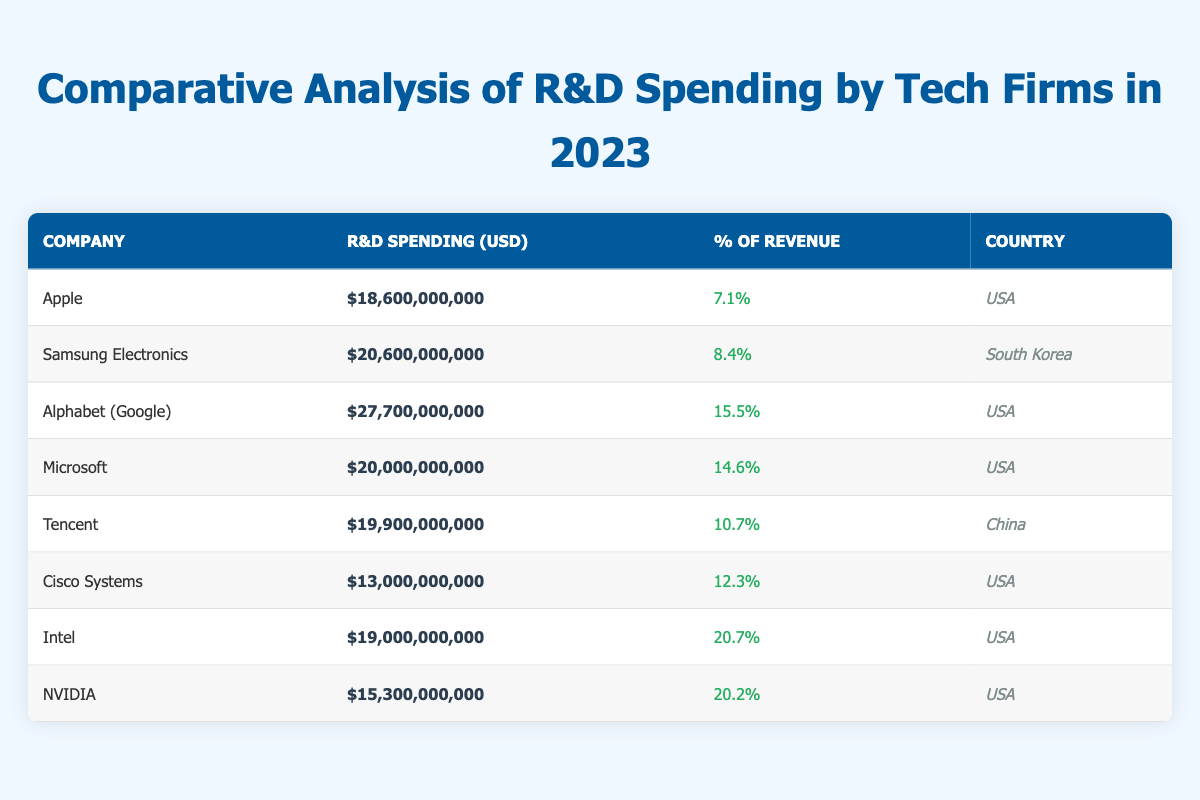What is the R&D spending of Alphabet (Google) in 2023? According to the table, Alphabet (Google) has R&D spending of $27,700,000,000. This value can be found directly in the R&D Spending (USD) column under the Company name.
Answer: $27,700,000,000 Which company spent the least on R&D in 2023? From the table, we can see that Cisco Systems has the least R&D spending at $13,000,000,000, as it is the lowest value in the R&D Spending (USD) column.
Answer: Cisco Systems What is the average percentage of revenue spent on R&D by the companies listed? To calculate the average percentage of revenue for the companies, we add the percentages (7.1 + 8.4 + 15.5 + 14.6 + 10.7 + 12.3 + 20.7 + 20.2) which equals 109.5%. Then we divide by the number of companies, which is 8. Therefore, the average is 109.5% / 8 = 13.6875%.
Answer: 13.69% Is Intel's R&D spending greater than Samsung Electronics'? Intel's R&D spending is $19,000,000,000 while Samsung Electronics' is $20,600,000,000. As we can see, $19,000,000,000 is less than $20,600,000,000. Hence, the statement is false.
Answer: No Which company has the highest percentage of revenue spent on R&D? The table shows that Intel has the highest percentage of revenue spent at 20.7%, which is greater than any other company listed in the table, making it the highest.
Answer: Intel What is the total R&D spending of all the companies from the USA? By summing the R&D spending for companies from the USA (Apple, Alphabet (Google), Microsoft, Cisco Systems, Intel, NVIDIA), we calculate: $18,600,000,000 + $27,700,000,000 + $20,000,000,000 + $13,000,000,000 + $19,000,000,000 + $15,300,000,000 = $113,600,000,000.
Answer: $113,600,000,000 Does Tencent's R&D spending represent more than 10% of its revenue? Tencent's R&D spending percentage is 10.7%, which is greater than 10%. Therefore, the statement is true.
Answer: Yes How much more does NVIDIA spend on R&D compared to Cisco Systems? NVIDIA's R&D spending is $15,300,000,000 and Cisco Systems' is $13,000,000,000. Therefore, the difference is calculated as $15,300,000,000 - $13,000,000,000 = $2,300,000,000.
Answer: $2,300,000,000 